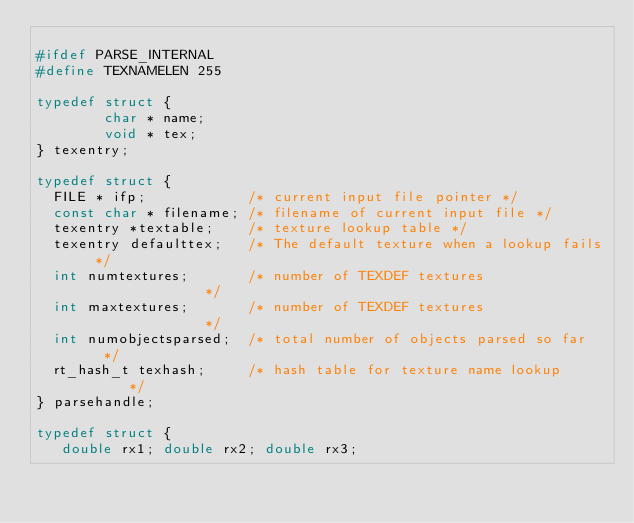Convert code to text. <code><loc_0><loc_0><loc_500><loc_500><_C_>
#ifdef PARSE_INTERNAL
#define TEXNAMELEN 255

typedef struct {
        char * name;
        void * tex;
} texentry;

typedef struct {
  FILE * ifp;            /* current input file pointer */
  const char * filename; /* filename of current input file */
  texentry *textable;    /* texture lookup table */
  texentry defaulttex;   /* The default texture when a lookup fails */
  int numtextures;       /* number of TEXDEF textures               */
  int maxtextures;       /* number of TEXDEF textures               */
  int numobjectsparsed;  /* total number of objects parsed so far   */
  rt_hash_t texhash;     /* hash table for texture name lookup      */
} parsehandle;  

typedef struct {
   double rx1; double rx2; double rx3;</code> 